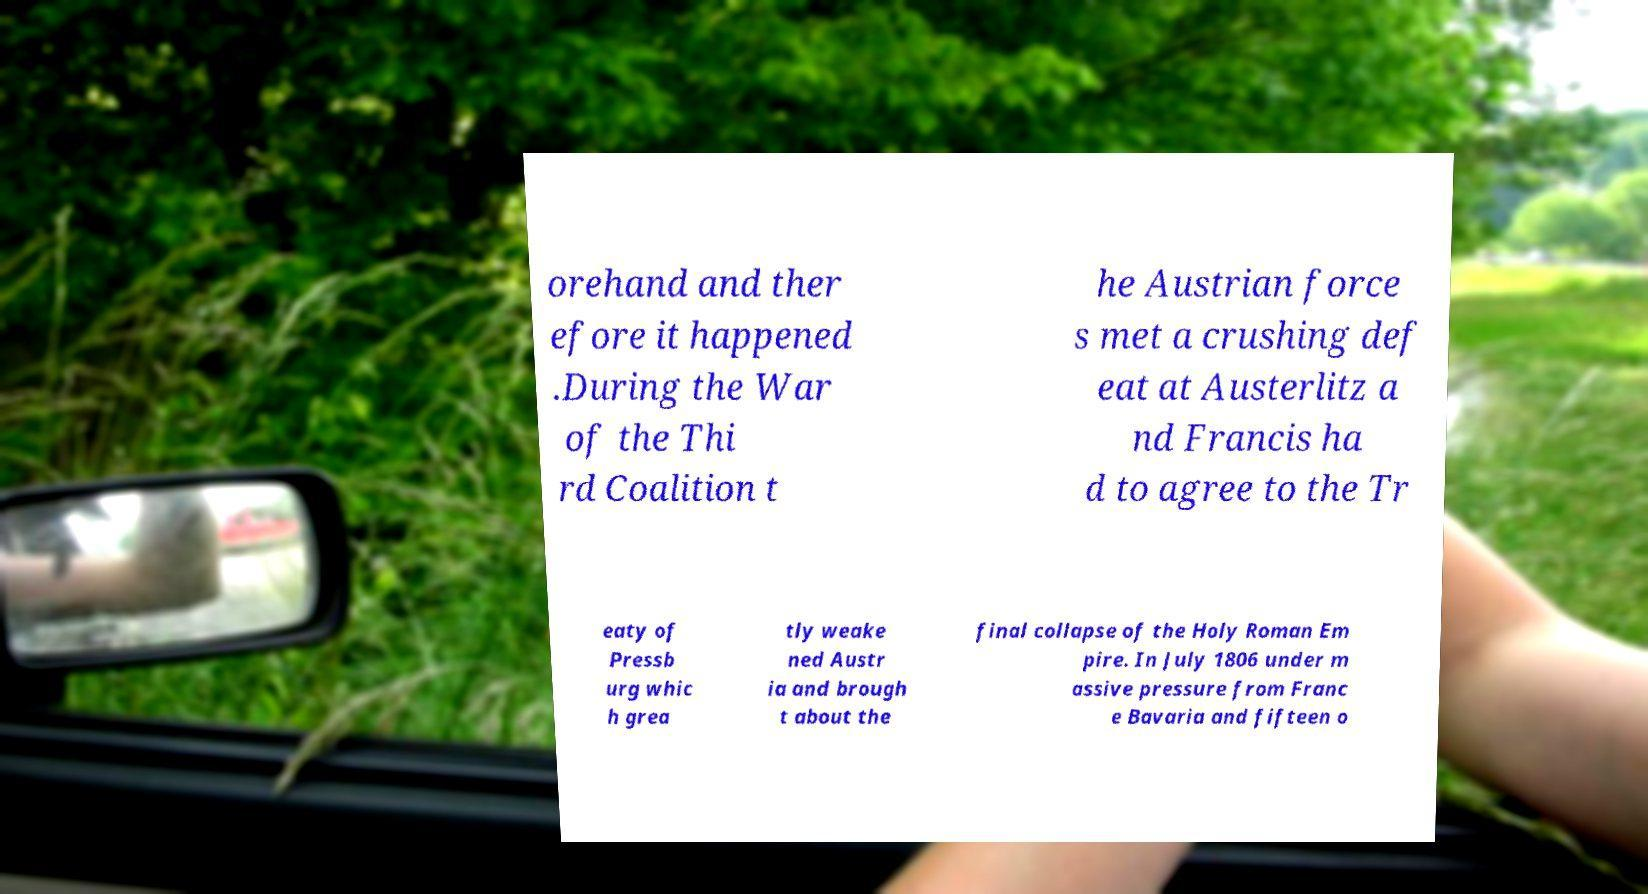There's text embedded in this image that I need extracted. Can you transcribe it verbatim? orehand and ther efore it happened .During the War of the Thi rd Coalition t he Austrian force s met a crushing def eat at Austerlitz a nd Francis ha d to agree to the Tr eaty of Pressb urg whic h grea tly weake ned Austr ia and brough t about the final collapse of the Holy Roman Em pire. In July 1806 under m assive pressure from Franc e Bavaria and fifteen o 